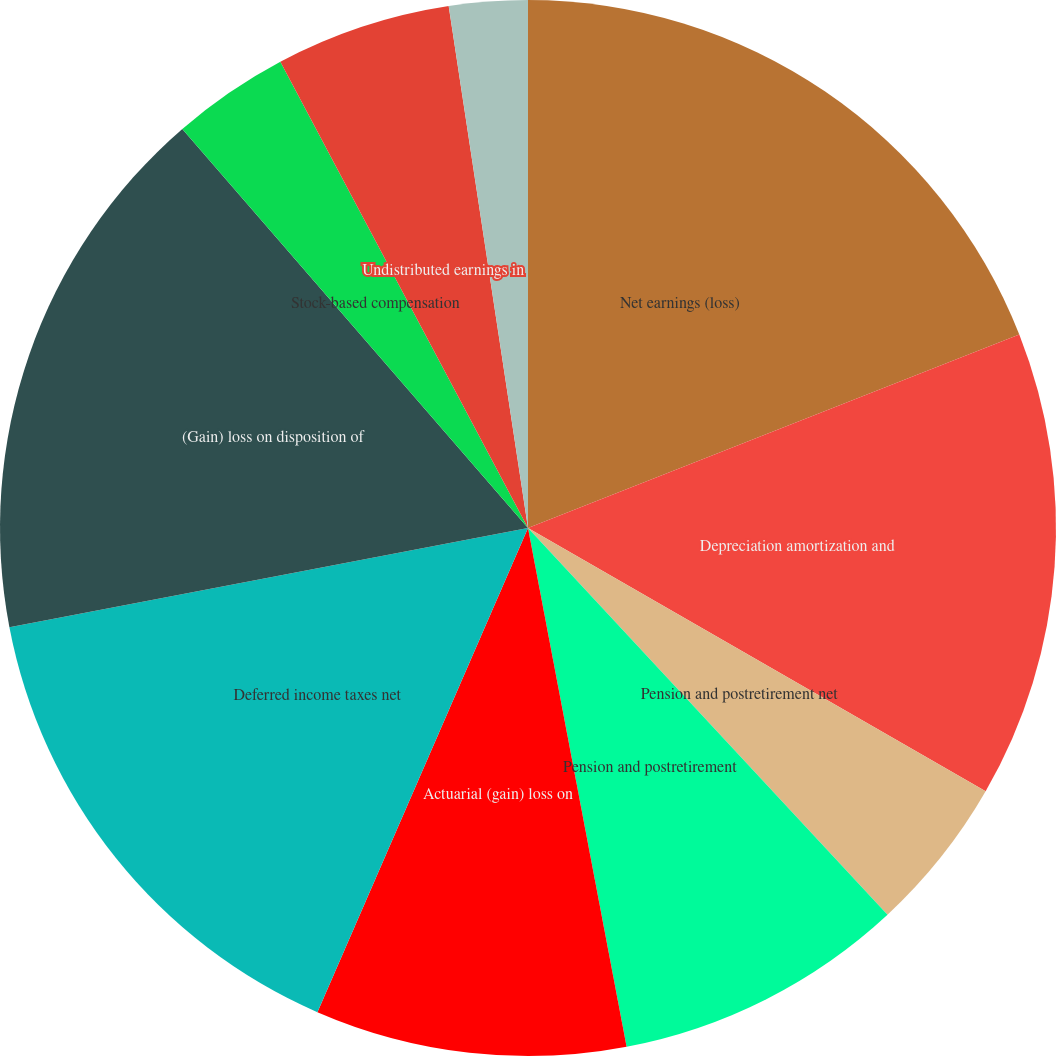<chart> <loc_0><loc_0><loc_500><loc_500><pie_chart><fcel>Net earnings (loss)<fcel>Depreciation amortization and<fcel>Pension and postretirement net<fcel>Pension and postretirement<fcel>Actuarial (gain) loss on<fcel>Deferred income taxes net<fcel>(Gain) loss on disposition of<fcel>Stock-based compensation<fcel>Undistributed earnings in<fcel>Other net<nl><fcel>19.03%<fcel>14.28%<fcel>4.77%<fcel>8.93%<fcel>9.52%<fcel>15.46%<fcel>16.65%<fcel>3.59%<fcel>5.37%<fcel>2.4%<nl></chart> 